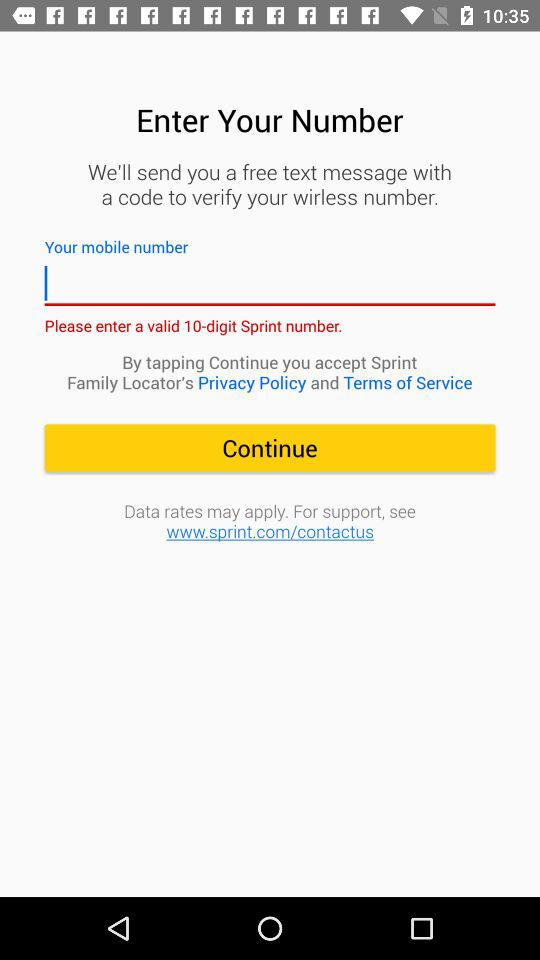How many digits does the Sprint number have? The Sprint number has 10 digits. 